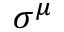Convert formula to latex. <formula><loc_0><loc_0><loc_500><loc_500>\sigma ^ { \mu }</formula> 